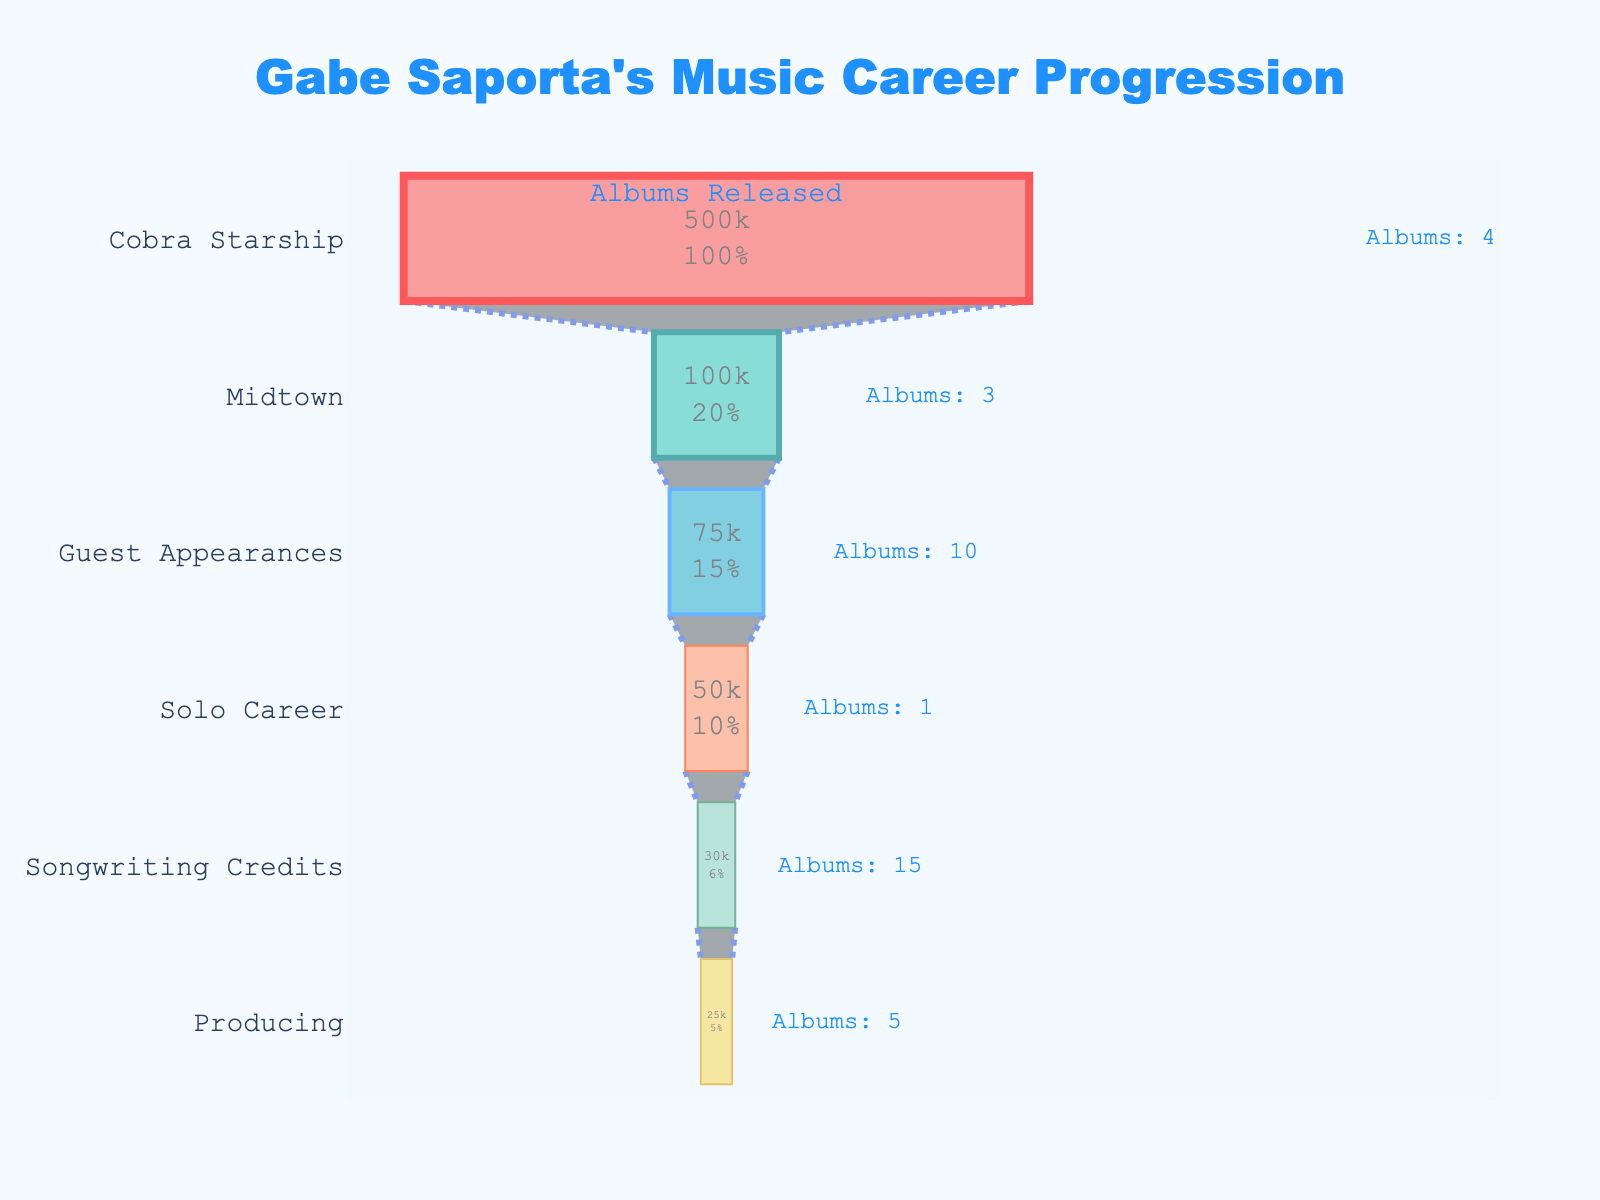What's the most popular stage of Gabe Saporta's music career in terms of fan numbers? The most popular stage in terms of fan numbers can be determined by looking at the stage with the highest number of fans on the funnel chart. This is "Cobra Starship" with 500,000 fans.
Answer: Cobra Starship Which stage had the least number of fans? The stage with the least number of fans is the one at the bottom of the funnel chart with the smallest value. This is "Producing" with 25,000 fans.
Answer: Producing How many albums were released during Gabe Saporta's time with Midtown? The number of albums released during the Midtown stage can be seen in the annotation on the funnel chart. Midtown had 3 albums released.
Answer: 3 Compare the number of fans in Midtown and Solo Career. Which has more fans and by how many? To compare, we look at the fan numbers for Midtown (100,000) and Solo Career (50,000). Midtown has more fans than Solo Career. The difference is 100,000 - 50,000 = 50,000.
Answer: Midtown, by 50,000 What are the stages with at least 4 albums released? To find this, we look at the annotations on the funnel chart for albums released and find stages with 4 or more albums. They are "Cobra Starship" with 4 albums, "Guest Appearances" with 10 albums, and "Songwriting Credits" with 15 albums.
Answer: Cobra Starship, Guest Appearances, Songwriting Credits Which stage has the lowest number of albums released? The stage with the lowest number of albums released can be found by looking at the annotations for albums across all stages. The "Solo Career" stage has the lowest with 1 album.
Answer: Solo Career If Gabe Saporta's fans from his "Guest Appearances" and "Songwriting Credits" stages are combined, how many fans do they total? To find the total, sum up the fans from "Guest Appearances" (75,000) and "Songwriting Credits" (30,000). The total is 75,000 + 30,000 = 105,000.
Answer: 105,000 What percentage of Gabe Saporta's total fans came from his time with Cobra Starship? First, sum up all the fan numbers: 100,000 (Midtown) + 500,000 (Cobra Starship) + 50,000 (Solo Career) + 75,000 (Guest Appearances) + 25,000 (Producing) + 30,000 (Songwriting Credits) = 780,000. Then, calculate the percentage for Cobra Starship: (500,000 / 780,000) * 100 ≈ 64.1%.
Answer: 64.1% List the stages where Gabe released more albums than the Solo Career stage. The Solo Career stage had 1 album. Stages with more than 1 album, based on the annotations, are "Midtown", "Cobra Starship", "Guest Appearances", "Producing", and "Songwriting Credits".
Answer: Midtown, Cobra Starship, Guest Appearances, Producing, Songwriting Credits 